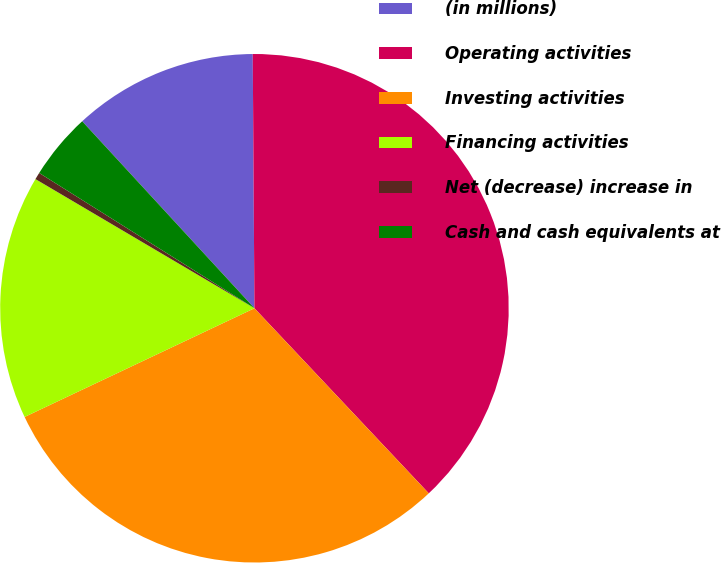<chart> <loc_0><loc_0><loc_500><loc_500><pie_chart><fcel>(in millions)<fcel>Operating activities<fcel>Investing activities<fcel>Financing activities<fcel>Net (decrease) increase in<fcel>Cash and cash equivalents at<nl><fcel>11.74%<fcel>38.08%<fcel>29.99%<fcel>15.51%<fcel>0.45%<fcel>4.22%<nl></chart> 